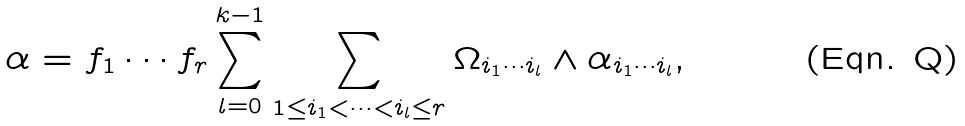Convert formula to latex. <formula><loc_0><loc_0><loc_500><loc_500>\alpha = f _ { 1 } \cdots f _ { r } \sum _ { l = 0 } ^ { k - 1 } \sum _ { 1 \leq i _ { 1 } < \cdots < i _ { l } \leq r } \Omega _ { i _ { 1 } \cdots i _ { l } } \wedge \alpha _ { i _ { 1 } \cdots i _ { l } } ,</formula> 